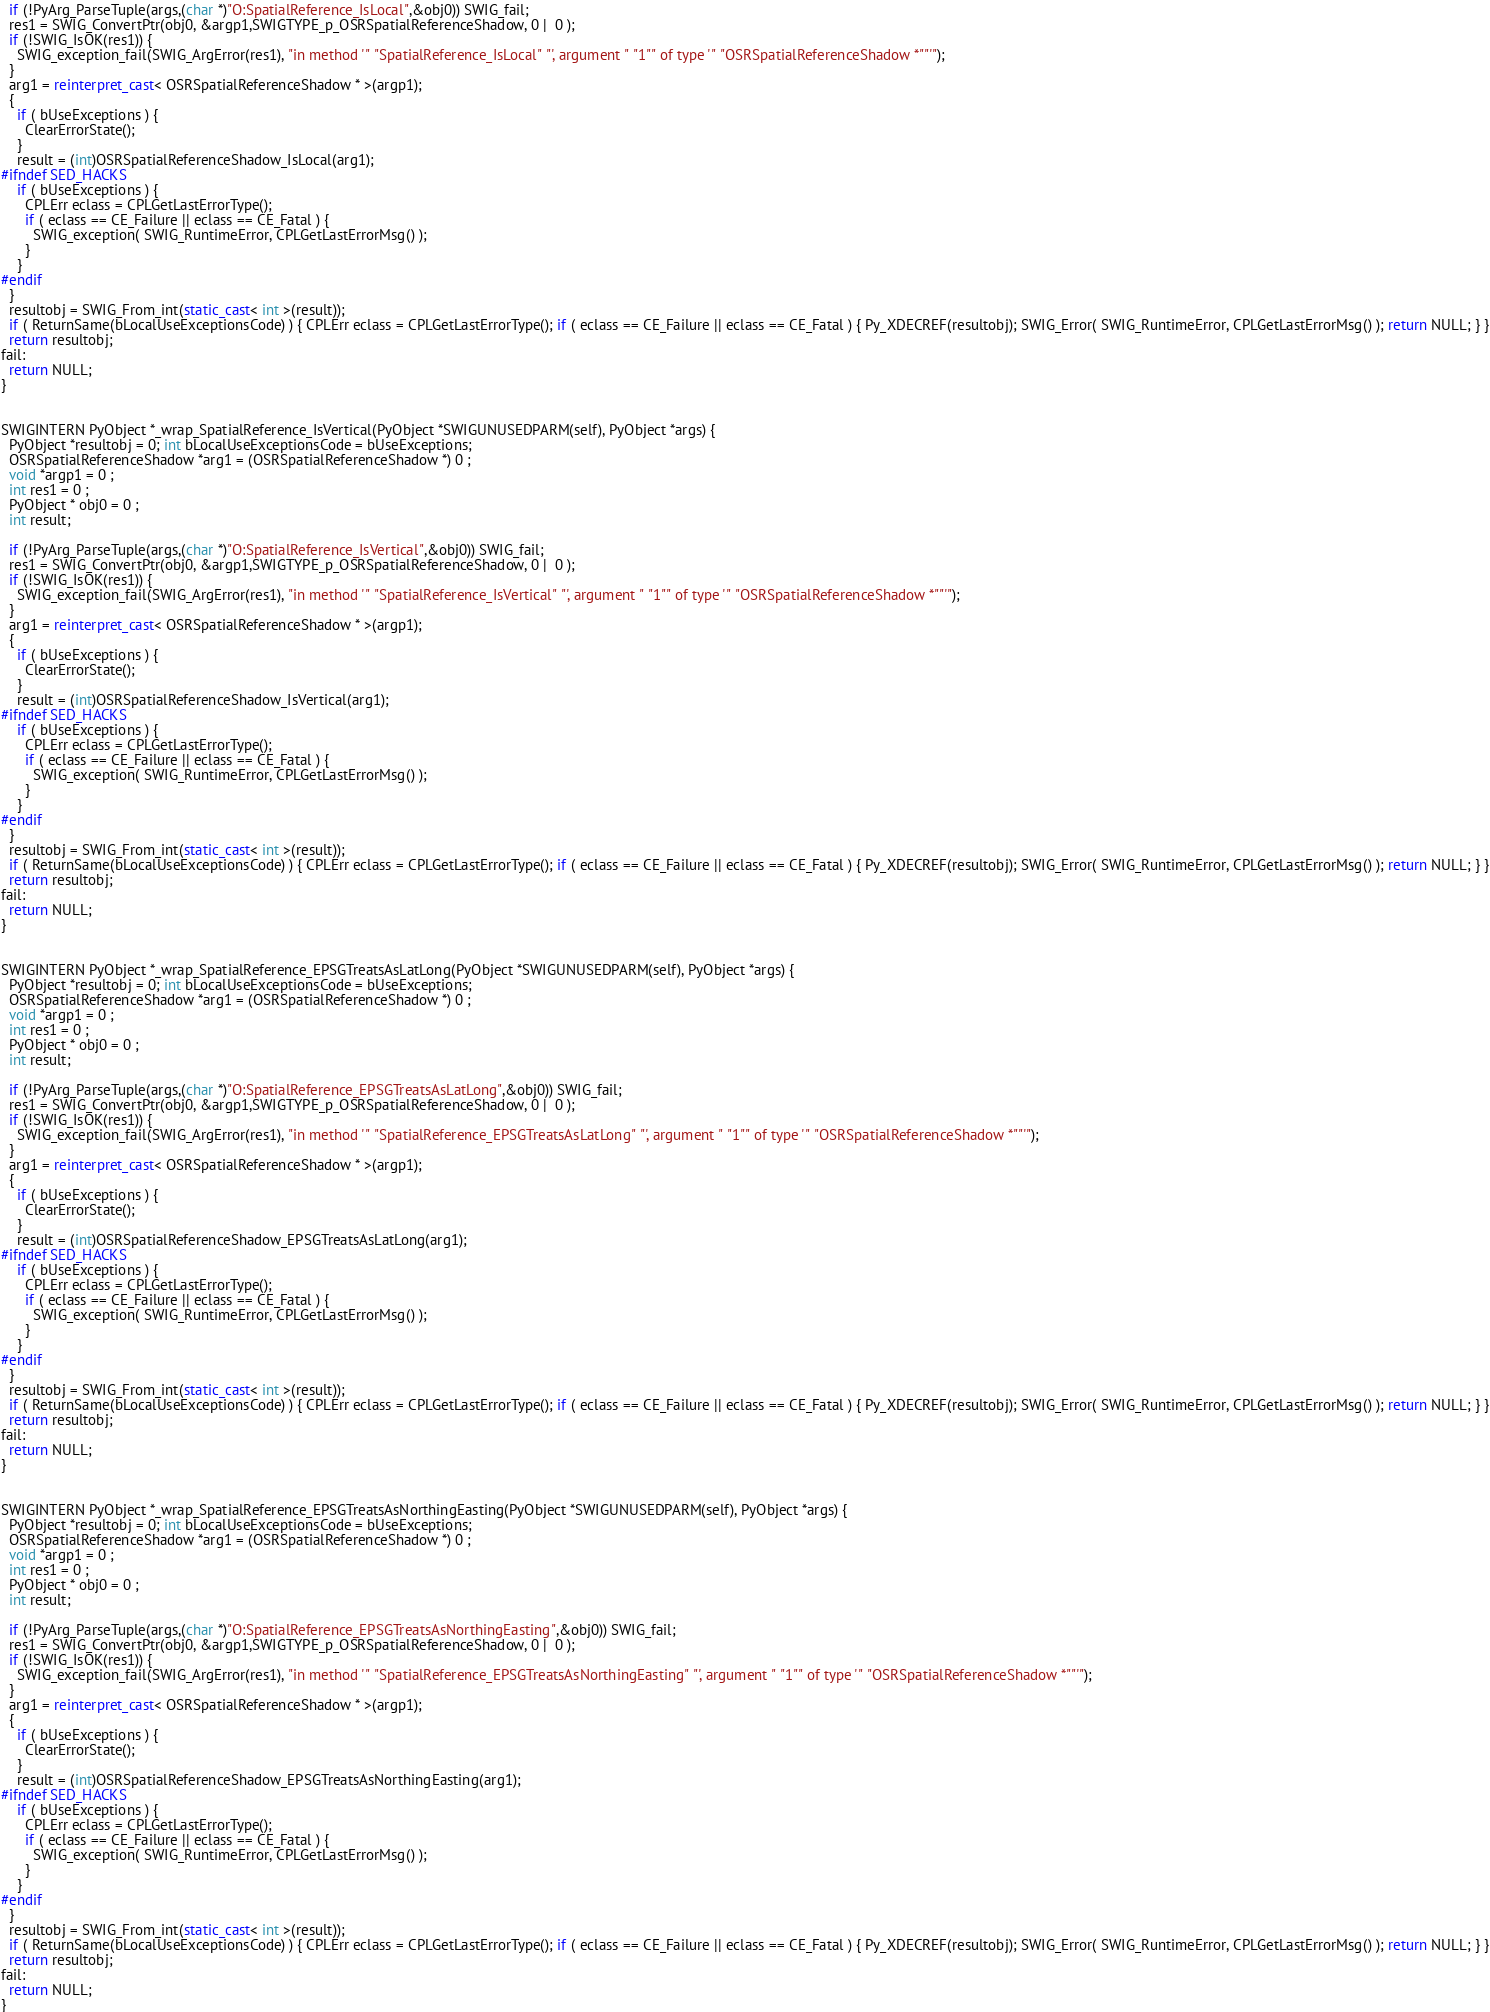Convert code to text. <code><loc_0><loc_0><loc_500><loc_500><_C++_>  if (!PyArg_ParseTuple(args,(char *)"O:SpatialReference_IsLocal",&obj0)) SWIG_fail;
  res1 = SWIG_ConvertPtr(obj0, &argp1,SWIGTYPE_p_OSRSpatialReferenceShadow, 0 |  0 );
  if (!SWIG_IsOK(res1)) {
    SWIG_exception_fail(SWIG_ArgError(res1), "in method '" "SpatialReference_IsLocal" "', argument " "1"" of type '" "OSRSpatialReferenceShadow *""'"); 
  }
  arg1 = reinterpret_cast< OSRSpatialReferenceShadow * >(argp1);
  {
    if ( bUseExceptions ) {
      ClearErrorState();
    }
    result = (int)OSRSpatialReferenceShadow_IsLocal(arg1);
#ifndef SED_HACKS
    if ( bUseExceptions ) {
      CPLErr eclass = CPLGetLastErrorType();
      if ( eclass == CE_Failure || eclass == CE_Fatal ) {
        SWIG_exception( SWIG_RuntimeError, CPLGetLastErrorMsg() );
      }
    }
#endif
  }
  resultobj = SWIG_From_int(static_cast< int >(result));
  if ( ReturnSame(bLocalUseExceptionsCode) ) { CPLErr eclass = CPLGetLastErrorType(); if ( eclass == CE_Failure || eclass == CE_Fatal ) { Py_XDECREF(resultobj); SWIG_Error( SWIG_RuntimeError, CPLGetLastErrorMsg() ); return NULL; } }
  return resultobj;
fail:
  return NULL;
}


SWIGINTERN PyObject *_wrap_SpatialReference_IsVertical(PyObject *SWIGUNUSEDPARM(self), PyObject *args) {
  PyObject *resultobj = 0; int bLocalUseExceptionsCode = bUseExceptions;
  OSRSpatialReferenceShadow *arg1 = (OSRSpatialReferenceShadow *) 0 ;
  void *argp1 = 0 ;
  int res1 = 0 ;
  PyObject * obj0 = 0 ;
  int result;
  
  if (!PyArg_ParseTuple(args,(char *)"O:SpatialReference_IsVertical",&obj0)) SWIG_fail;
  res1 = SWIG_ConvertPtr(obj0, &argp1,SWIGTYPE_p_OSRSpatialReferenceShadow, 0 |  0 );
  if (!SWIG_IsOK(res1)) {
    SWIG_exception_fail(SWIG_ArgError(res1), "in method '" "SpatialReference_IsVertical" "', argument " "1"" of type '" "OSRSpatialReferenceShadow *""'"); 
  }
  arg1 = reinterpret_cast< OSRSpatialReferenceShadow * >(argp1);
  {
    if ( bUseExceptions ) {
      ClearErrorState();
    }
    result = (int)OSRSpatialReferenceShadow_IsVertical(arg1);
#ifndef SED_HACKS
    if ( bUseExceptions ) {
      CPLErr eclass = CPLGetLastErrorType();
      if ( eclass == CE_Failure || eclass == CE_Fatal ) {
        SWIG_exception( SWIG_RuntimeError, CPLGetLastErrorMsg() );
      }
    }
#endif
  }
  resultobj = SWIG_From_int(static_cast< int >(result));
  if ( ReturnSame(bLocalUseExceptionsCode) ) { CPLErr eclass = CPLGetLastErrorType(); if ( eclass == CE_Failure || eclass == CE_Fatal ) { Py_XDECREF(resultobj); SWIG_Error( SWIG_RuntimeError, CPLGetLastErrorMsg() ); return NULL; } }
  return resultobj;
fail:
  return NULL;
}


SWIGINTERN PyObject *_wrap_SpatialReference_EPSGTreatsAsLatLong(PyObject *SWIGUNUSEDPARM(self), PyObject *args) {
  PyObject *resultobj = 0; int bLocalUseExceptionsCode = bUseExceptions;
  OSRSpatialReferenceShadow *arg1 = (OSRSpatialReferenceShadow *) 0 ;
  void *argp1 = 0 ;
  int res1 = 0 ;
  PyObject * obj0 = 0 ;
  int result;
  
  if (!PyArg_ParseTuple(args,(char *)"O:SpatialReference_EPSGTreatsAsLatLong",&obj0)) SWIG_fail;
  res1 = SWIG_ConvertPtr(obj0, &argp1,SWIGTYPE_p_OSRSpatialReferenceShadow, 0 |  0 );
  if (!SWIG_IsOK(res1)) {
    SWIG_exception_fail(SWIG_ArgError(res1), "in method '" "SpatialReference_EPSGTreatsAsLatLong" "', argument " "1"" of type '" "OSRSpatialReferenceShadow *""'"); 
  }
  arg1 = reinterpret_cast< OSRSpatialReferenceShadow * >(argp1);
  {
    if ( bUseExceptions ) {
      ClearErrorState();
    }
    result = (int)OSRSpatialReferenceShadow_EPSGTreatsAsLatLong(arg1);
#ifndef SED_HACKS
    if ( bUseExceptions ) {
      CPLErr eclass = CPLGetLastErrorType();
      if ( eclass == CE_Failure || eclass == CE_Fatal ) {
        SWIG_exception( SWIG_RuntimeError, CPLGetLastErrorMsg() );
      }
    }
#endif
  }
  resultobj = SWIG_From_int(static_cast< int >(result));
  if ( ReturnSame(bLocalUseExceptionsCode) ) { CPLErr eclass = CPLGetLastErrorType(); if ( eclass == CE_Failure || eclass == CE_Fatal ) { Py_XDECREF(resultobj); SWIG_Error( SWIG_RuntimeError, CPLGetLastErrorMsg() ); return NULL; } }
  return resultobj;
fail:
  return NULL;
}


SWIGINTERN PyObject *_wrap_SpatialReference_EPSGTreatsAsNorthingEasting(PyObject *SWIGUNUSEDPARM(self), PyObject *args) {
  PyObject *resultobj = 0; int bLocalUseExceptionsCode = bUseExceptions;
  OSRSpatialReferenceShadow *arg1 = (OSRSpatialReferenceShadow *) 0 ;
  void *argp1 = 0 ;
  int res1 = 0 ;
  PyObject * obj0 = 0 ;
  int result;
  
  if (!PyArg_ParseTuple(args,(char *)"O:SpatialReference_EPSGTreatsAsNorthingEasting",&obj0)) SWIG_fail;
  res1 = SWIG_ConvertPtr(obj0, &argp1,SWIGTYPE_p_OSRSpatialReferenceShadow, 0 |  0 );
  if (!SWIG_IsOK(res1)) {
    SWIG_exception_fail(SWIG_ArgError(res1), "in method '" "SpatialReference_EPSGTreatsAsNorthingEasting" "', argument " "1"" of type '" "OSRSpatialReferenceShadow *""'"); 
  }
  arg1 = reinterpret_cast< OSRSpatialReferenceShadow * >(argp1);
  {
    if ( bUseExceptions ) {
      ClearErrorState();
    }
    result = (int)OSRSpatialReferenceShadow_EPSGTreatsAsNorthingEasting(arg1);
#ifndef SED_HACKS
    if ( bUseExceptions ) {
      CPLErr eclass = CPLGetLastErrorType();
      if ( eclass == CE_Failure || eclass == CE_Fatal ) {
        SWIG_exception( SWIG_RuntimeError, CPLGetLastErrorMsg() );
      }
    }
#endif
  }
  resultobj = SWIG_From_int(static_cast< int >(result));
  if ( ReturnSame(bLocalUseExceptionsCode) ) { CPLErr eclass = CPLGetLastErrorType(); if ( eclass == CE_Failure || eclass == CE_Fatal ) { Py_XDECREF(resultobj); SWIG_Error( SWIG_RuntimeError, CPLGetLastErrorMsg() ); return NULL; } }
  return resultobj;
fail:
  return NULL;
}

</code> 